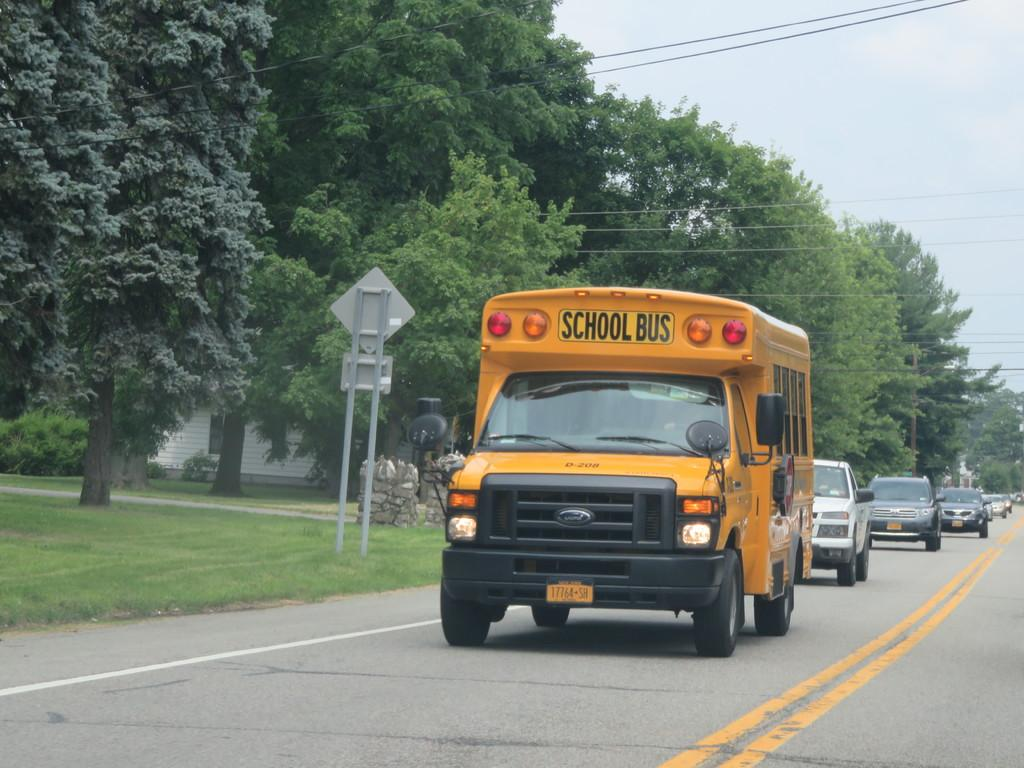What can be seen on the road in the image? There are vehicles on the road in the image. What type of vegetation is visible in the background of the image? There are trees in the background of the image. What structures can be seen in the background of the image? There are boards with poles and a house in the background of the image. What else is present in the background of the image? There is grass, a glass window, and wires in the background of the image. What is visible at the top of the image? The sky is visible at the top of the image. Can you tell me how many times the wire is used in the image? There is no mention of a wire in the image; it only mentions wires. How does the park appear in the image? There is no park present in the image. 